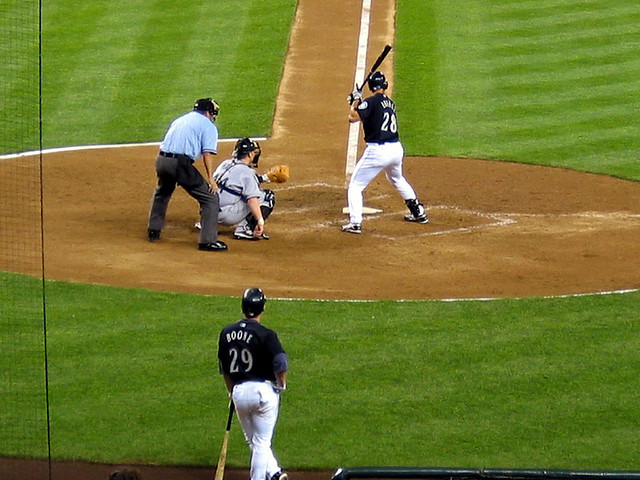Please transcribe the text information in this image. 28 BOOIE 29 